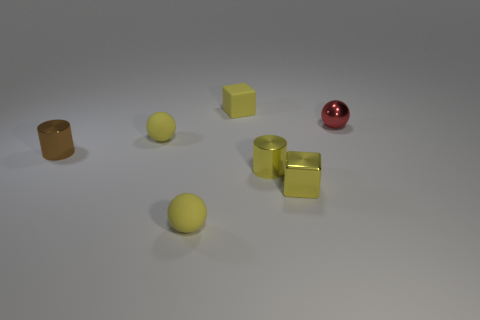The brown shiny object has what size?
Offer a very short reply. Small. Are there an equal number of small yellow matte balls behind the small red metal ball and yellow balls?
Your response must be concise. No. How many other objects are there of the same color as the small shiny sphere?
Ensure brevity in your answer.  0. What color is the tiny ball that is behind the yellow cylinder and to the left of the tiny red metal thing?
Offer a terse response. Yellow. There is a cylinder to the left of the yellow cube behind the small brown shiny cylinder in front of the red thing; how big is it?
Your answer should be very brief. Small. What number of objects are either yellow blocks that are behind the red thing or yellow matte balls behind the tiny brown thing?
Your answer should be very brief. 2. The tiny brown shiny object is what shape?
Your response must be concise. Cylinder. What number of other objects are the same material as the small red thing?
Your answer should be very brief. 3. There is another shiny object that is the same shape as the small brown thing; what is its size?
Give a very brief answer. Small. The ball in front of the metal cylinder to the left of the small cube that is behind the tiny metallic cube is made of what material?
Your response must be concise. Rubber. 